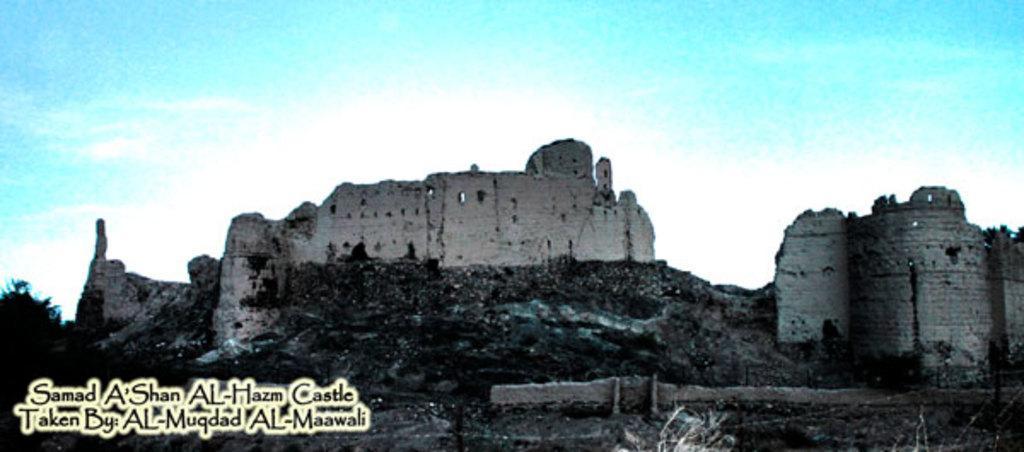Can you describe this image briefly? This picture is blur, in this picture we can see fort and tree. In the bottom left side of the image we can see text. In the background of the image we can see the sky. 